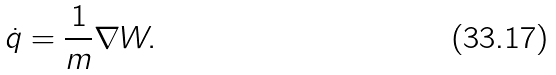Convert formula to latex. <formula><loc_0><loc_0><loc_500><loc_500>\dot { q } = \frac { 1 } { m } \nabla W .</formula> 